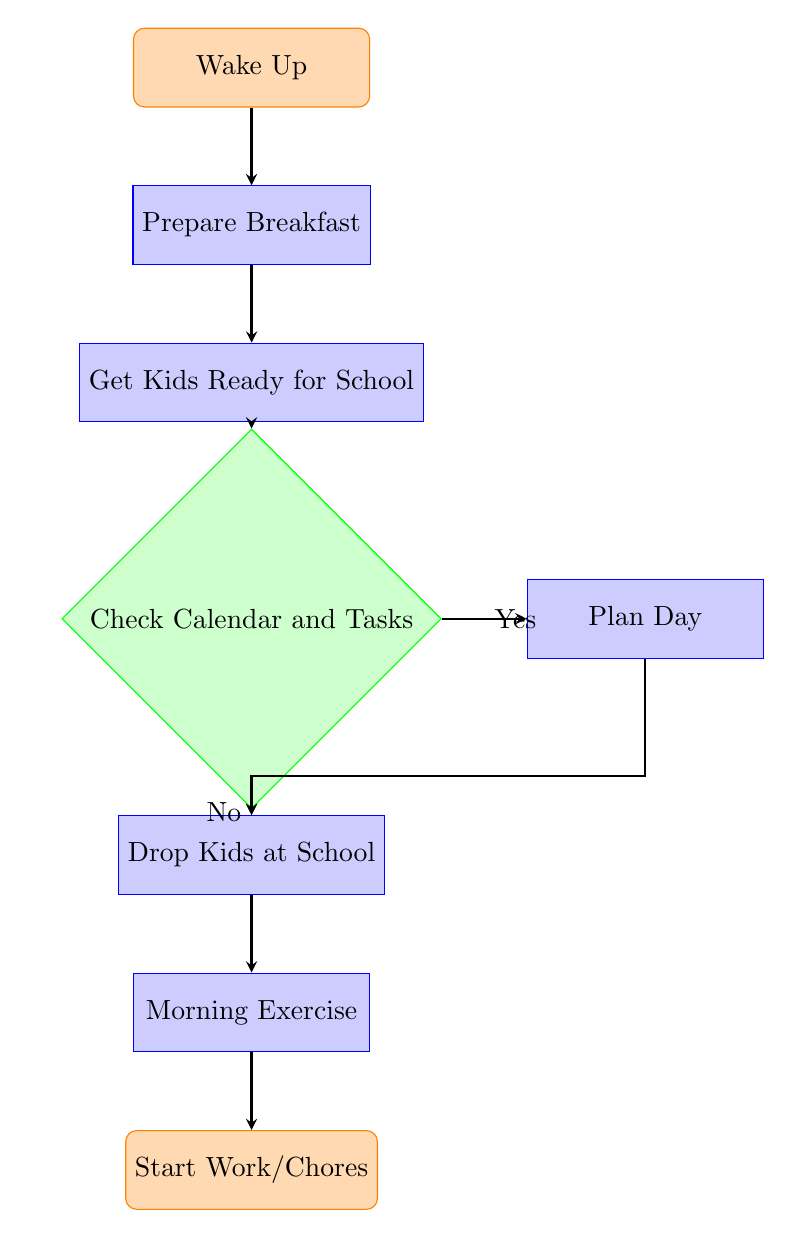What is the starting point of the morning routine? The starting point of the morning routine is indicated as "Wake Up" in the diagram. This is the first node that initiates the flow of activities.
Answer: Wake Up How many processes are there in total? The processes in the diagram are "Prepare Breakfast," "Get Kids Ready for School," "Plan Day," "Drop Kids at School," and "Morning Exercise." Counting these gives a total of five processes.
Answer: Five What happens if you answer "No" to the question in the decision node? If the answer is "No" to "Check Calendar and Tasks," the flow leads directly to "Drop Kids at School." This indicates that if there are no tasks or plans to check, you proceed with dropping the kids off.
Answer: Drop Kids at School How many nodes are there in the entire diagram? The diagram consists of eight nodes, which include the start node, seven processes, and one decision node. Counting all these together results in eight nodes.
Answer: Eight What is the final action taken in the morning routine? The final action of the morning routine is represented as "Start Work/Chores," which is the last node in the diagram indicating the conclusion of the morning routine tasks.
Answer: Start Work/Chores If breakfast takes longer, what is the likely impact on the morning routine? If breakfast takes longer, it could delay the subsequent activities, particularly "Get Kids Ready for School" and any tasks checked thereafter, potentially affecting the entire schedule.
Answer: Delay What node comes directly after "Get Kids Ready for School"? The node that comes directly after "Get Kids Ready for School" is "Check Calendar and Tasks," indicating the next step in the process of getting organized for the day.
Answer: Check Calendar and Tasks What is the decision point about in the morning routine? The decision point is about whether to "Check Calendar and Tasks." Depending on the answer, one can plan their day or move directly to dropping kids off at school.
Answer: Check Calendar and Tasks 